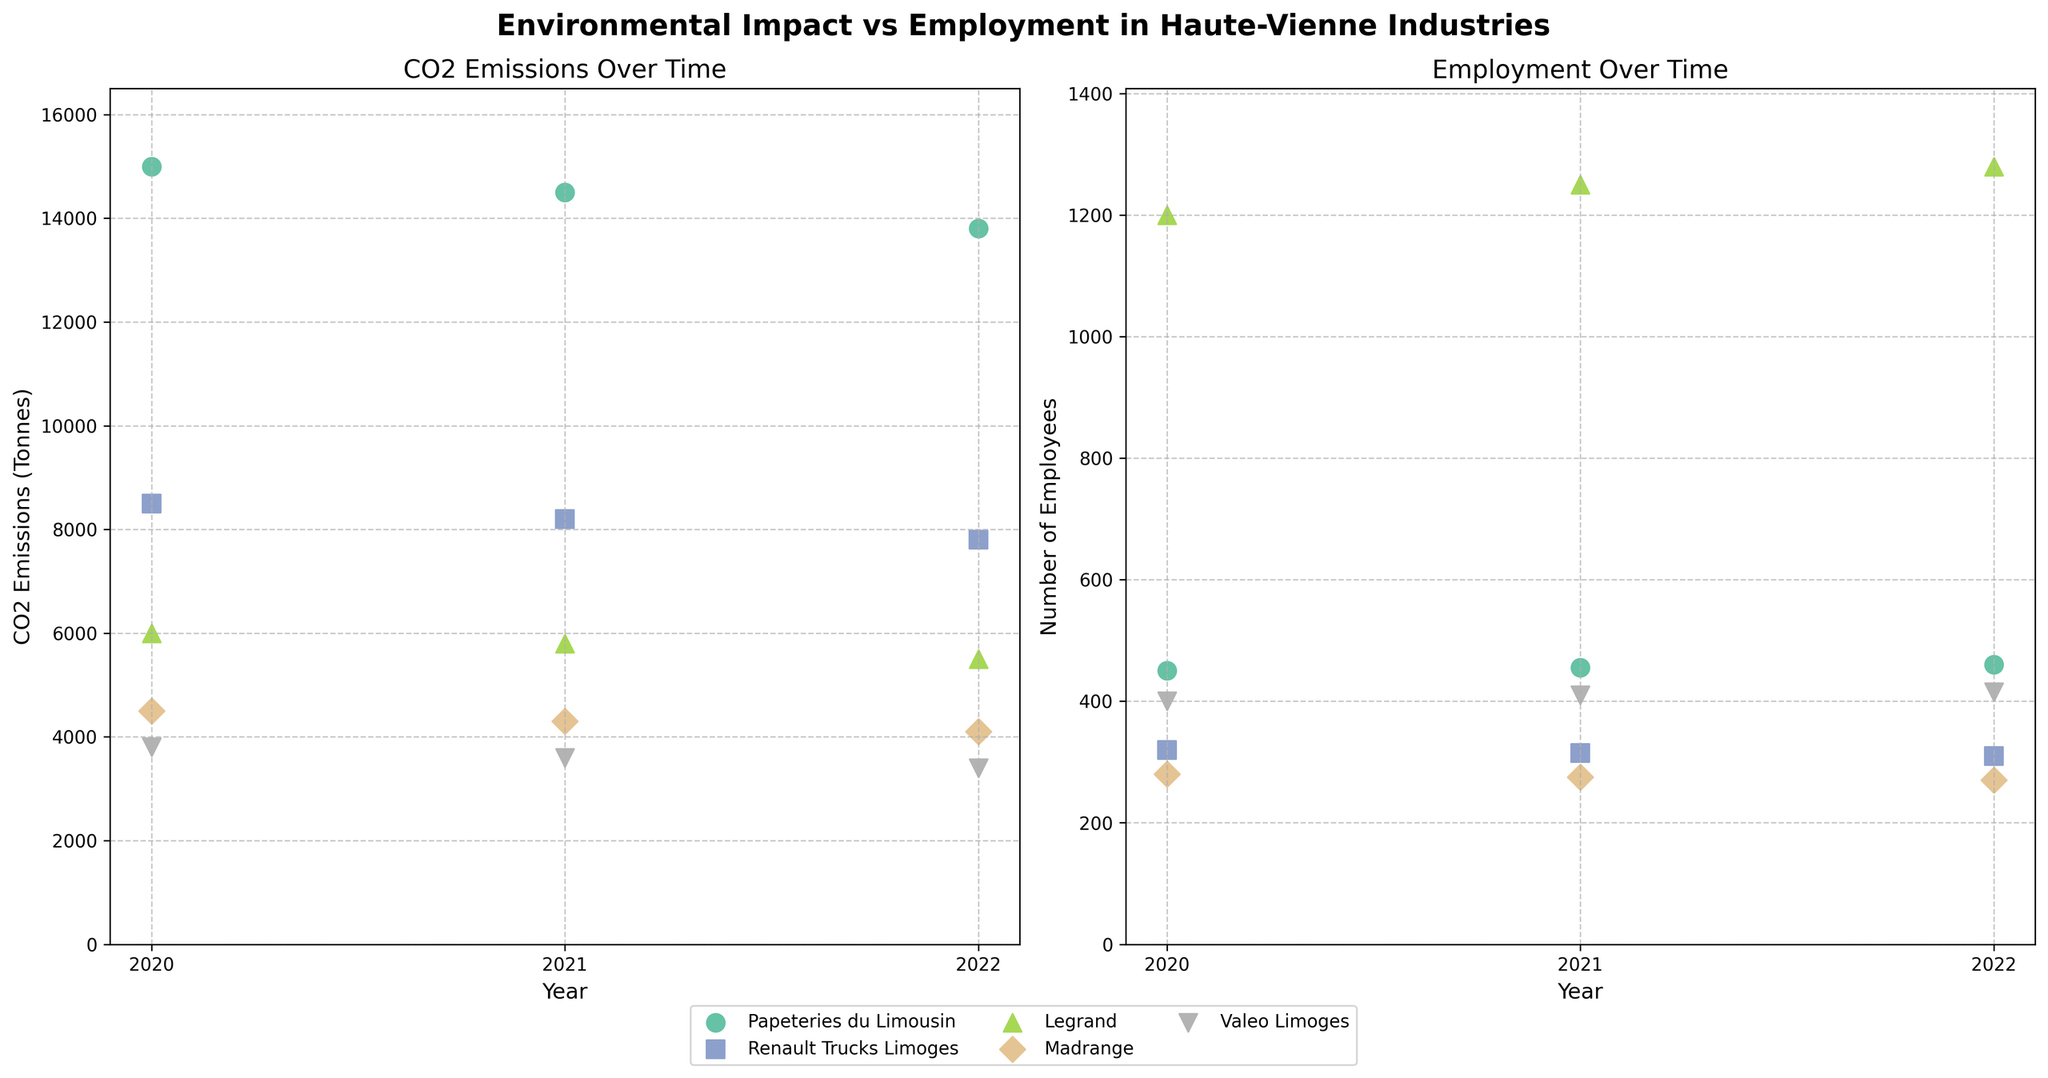What is the title of the figure? The title can be found at the top of the figure and provides a summary of the plot's content. In this case, it will be 'Environmental Impact vs Employment in Haute-Vienne Industries' as specified in the code.
Answer: Environmental Impact vs Employment in Haute-Vienne Industries What does the x-axis represent in both subplots? The x-axis in both subplots indicates the time period over which the data is plotted. Specifically, it represents the 'Year' for each subplot.
Answer: Year What trend can be observed in the CO2 emissions of Papeteries du Limousin from 2020 to 2022? This requires looking at the first subplot and observing the data points for Papeteries du Limousin. The CO2 emissions decrease over the years from 2020 to 2022.
Answer: Decreasing trend Which industry shows the largest number of employees in 2020? To answer this, refer to the second subplot and look for the highest data point in the year 2020. Legrand has the highest number of employees in 2020.
Answer: Legrand By how much did the CO2 emissions of Renault Trucks Limoges decrease from 2020 to 2022? First, note the CO2 emissions for Renault Trucks Limoges in 2020 (8500 tonnes) and in 2022 (7800 tonnes). The difference is 8500 - 7800 = 700.
Answer: 700 tonnes How do the number of employees at Legrand change between 2020 and 2022? Look at the second subplot for the data points of Legrand in the years 2020 and 2022. The number of employees increased from 1200 to 1280, which is a difference of 1280 - 1200 = 80.
Answer: Increased by 80 Which industry had the lowest CO2 emissions in 2021? Check the first subplot for the year 2021 and identify the industry with the lowest point. Valeo Limoges shows the lowest CO2 emissions in 2021.
Answer: Valeo Limoges Is there an overall trend in employment numbers for Madrange from 2020 to 2022? Refer to the second subplot and see the trend of data points for Madrange. There is a slight decrease in the number of employees from 280 in 2020 to 270 in 2022.
Answer: Decreasing trend 